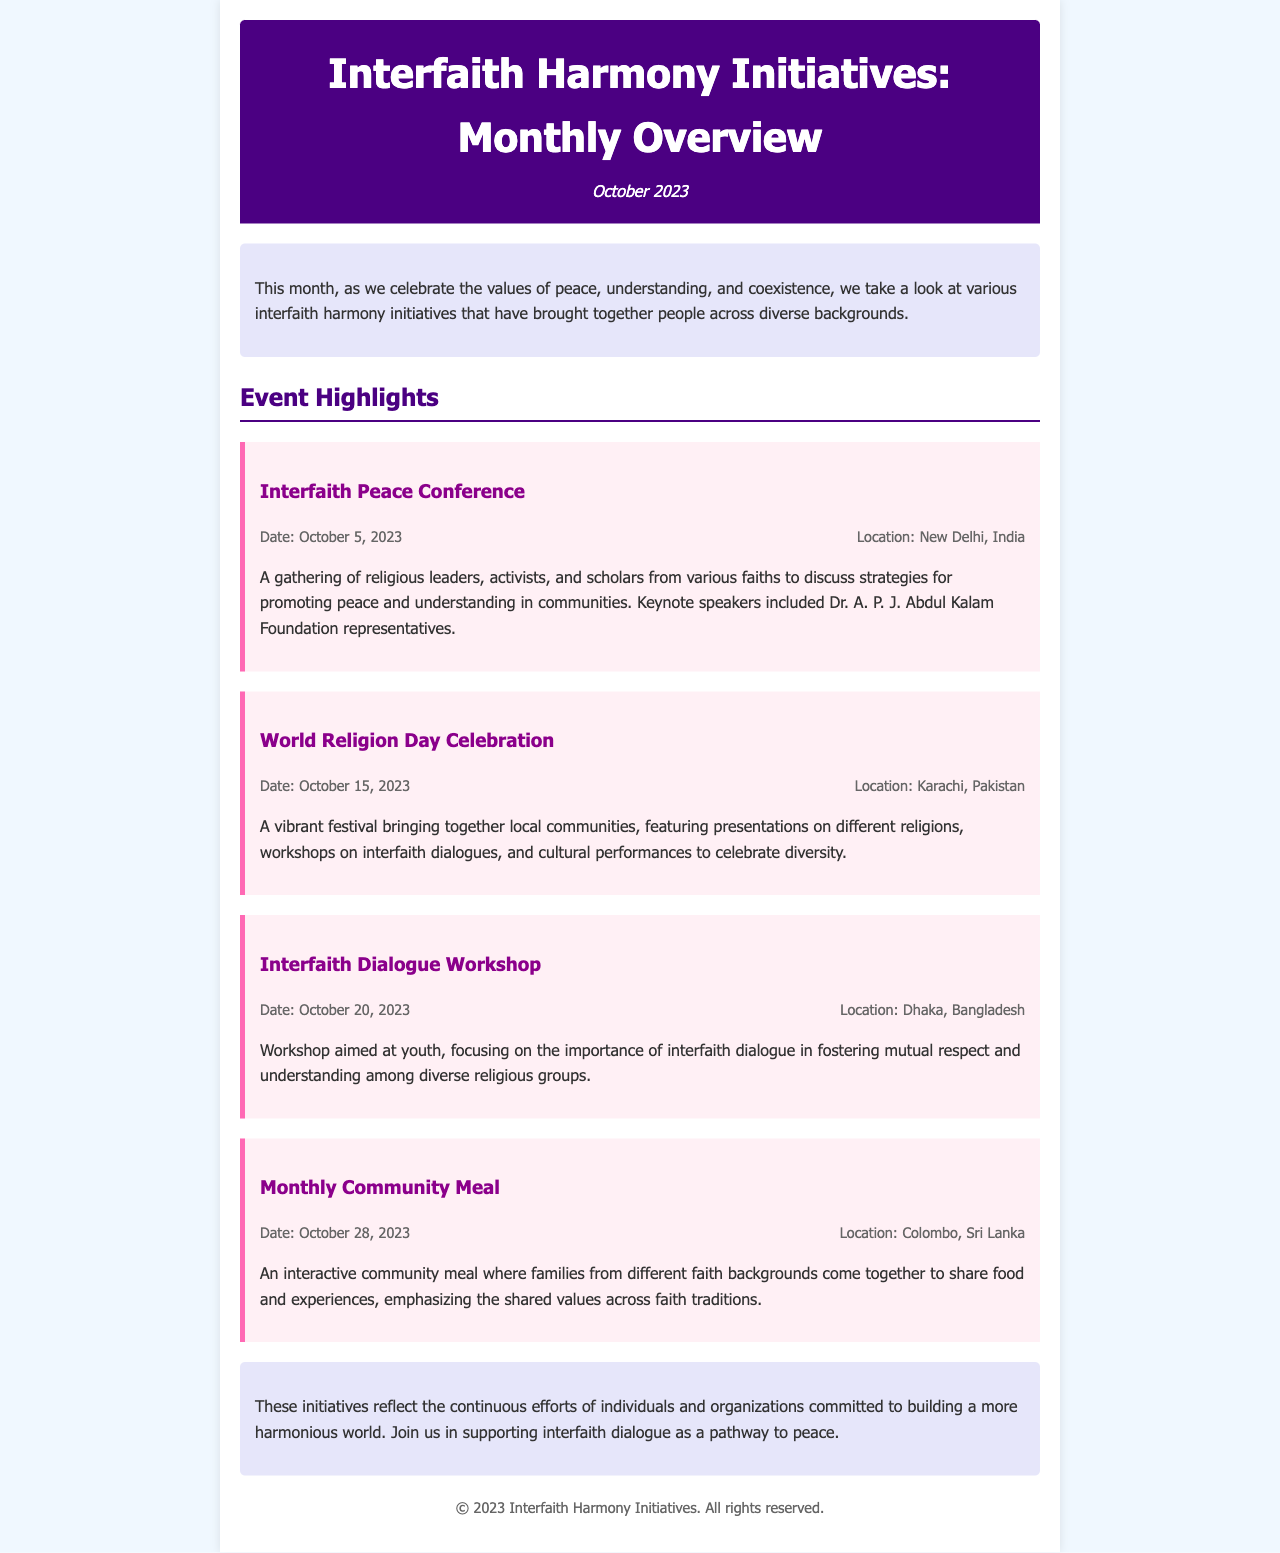What is the date of the Interfaith Peace Conference? The document states that the Interfaith Peace Conference took place on October 5, 2023.
Answer: October 5, 2023 Where was the World Religion Day Celebration held? The location for the World Religion Day Celebration is mentioned as Karachi, Pakistan.
Answer: Karachi, Pakistan What type of event was held on October 20, 2023? The event held on this date is specified as an Interfaith Dialogue Workshop.
Answer: Interfaith Dialogue Workshop Which community event emphasizes shared values across faith traditions? The document highlights the Monthly Community Meal as an event that emphasizes shared values across faith traditions.
Answer: Monthly Community Meal How many events are highlighted in the newsletter? The document lists four highlighted events as part of the monthly overview.
Answer: Four What is the main goal of the Interfaith Dialogue Workshop? The document states that the workshop focuses on fostering mutual respect and understanding among diverse religious groups.
Answer: Fostering mutual respect and understanding Which country hosted the workshop aimed at youth? The Interfaith Dialogue Workshop is hosted in Dhaka, Bangladesh.
Answer: Dhaka, Bangladesh What overarching theme is celebrated in the newsletter? The newsletter celebrates the values of peace, understanding, and coexistence.
Answer: Peace, understanding, and coexistence 